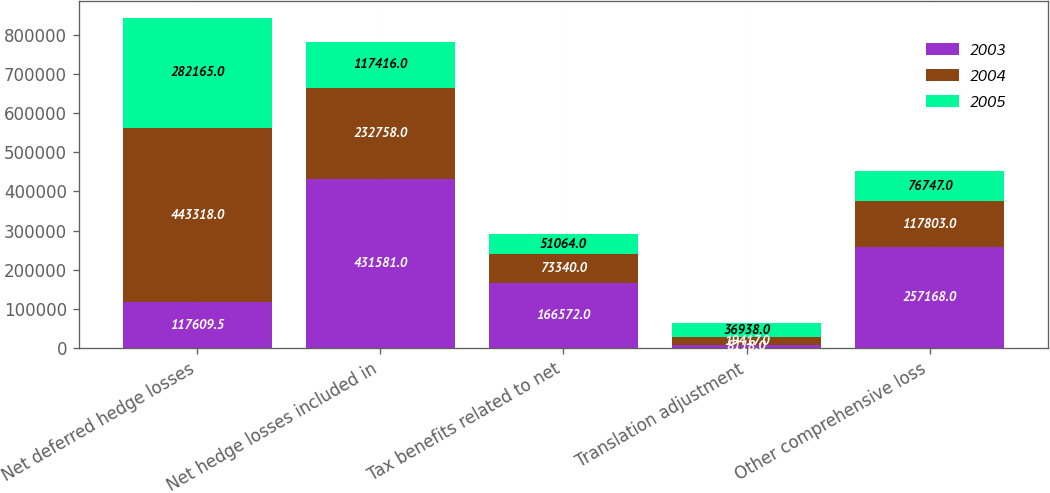Convert chart. <chart><loc_0><loc_0><loc_500><loc_500><stacked_bar_chart><ecel><fcel>Net deferred hedge losses<fcel>Net hedge losses included in<fcel>Tax benefits related to net<fcel>Translation adjustment<fcel>Other comprehensive loss<nl><fcel>2003<fcel>117610<fcel>431581<fcel>166572<fcel>8118<fcel>257168<nl><fcel>2004<fcel>443318<fcel>232758<fcel>73340<fcel>19417<fcel>117803<nl><fcel>2005<fcel>282165<fcel>117416<fcel>51064<fcel>36938<fcel>76747<nl></chart> 